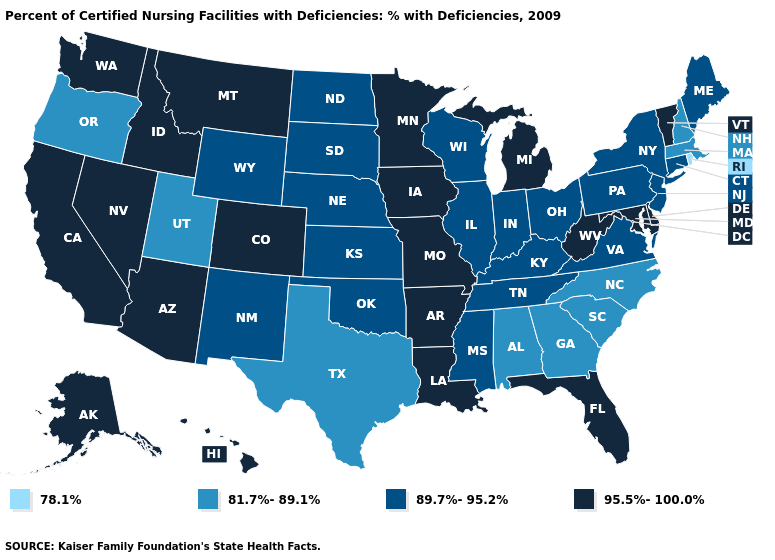What is the highest value in the South ?
Keep it brief. 95.5%-100.0%. Which states have the lowest value in the West?
Concise answer only. Oregon, Utah. What is the value of South Dakota?
Answer briefly. 89.7%-95.2%. Does New Mexico have the lowest value in the West?
Keep it brief. No. Does the map have missing data?
Give a very brief answer. No. What is the value of Tennessee?
Quick response, please. 89.7%-95.2%. Does the first symbol in the legend represent the smallest category?
Answer briefly. Yes. What is the value of New Mexico?
Write a very short answer. 89.7%-95.2%. Among the states that border Pennsylvania , which have the lowest value?
Give a very brief answer. New Jersey, New York, Ohio. Name the states that have a value in the range 89.7%-95.2%?
Give a very brief answer. Connecticut, Illinois, Indiana, Kansas, Kentucky, Maine, Mississippi, Nebraska, New Jersey, New Mexico, New York, North Dakota, Ohio, Oklahoma, Pennsylvania, South Dakota, Tennessee, Virginia, Wisconsin, Wyoming. Does Wyoming have a higher value than North Dakota?
Be succinct. No. Among the states that border Arkansas , does Missouri have the lowest value?
Keep it brief. No. Does the first symbol in the legend represent the smallest category?
Answer briefly. Yes. What is the lowest value in the USA?
Write a very short answer. 78.1%. 